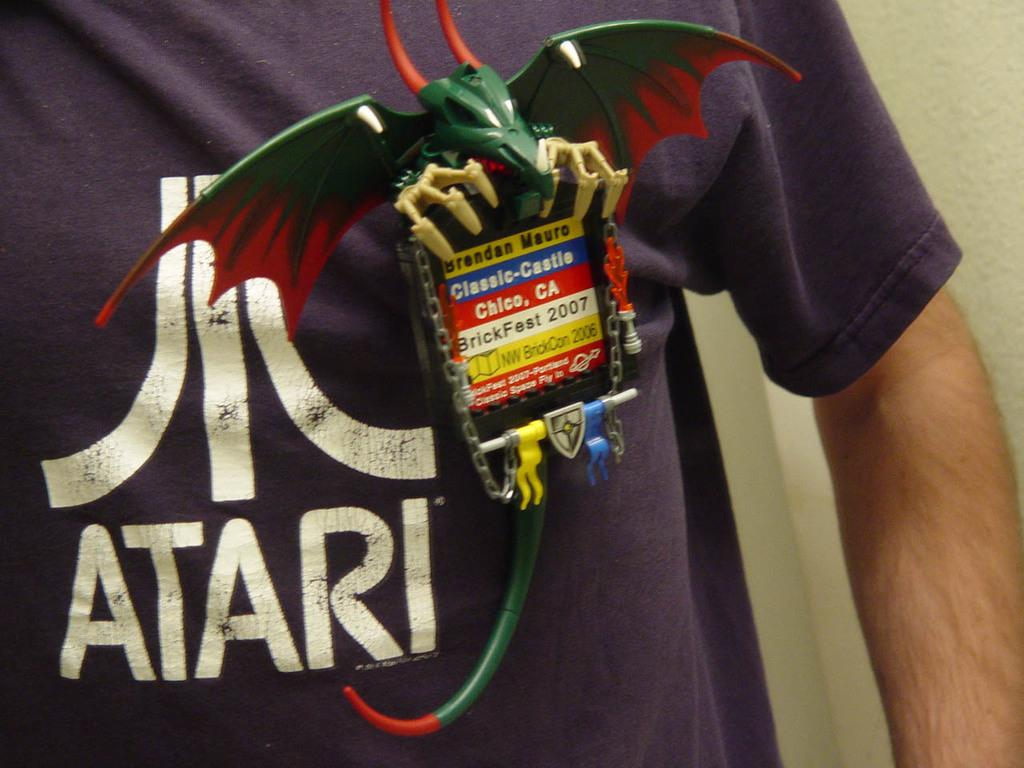Provide a one-sentence caption for the provided image. A person in an Atari t-shirt shows off a dragon shaped badge. 